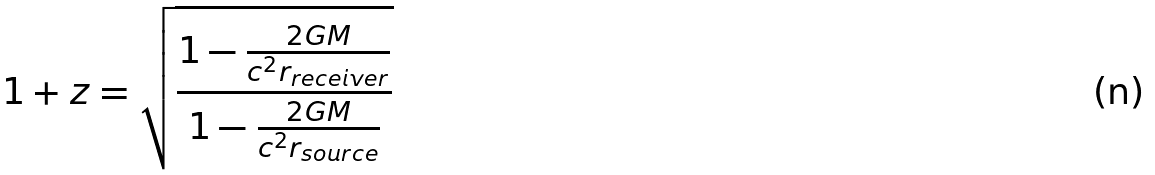Convert formula to latex. <formula><loc_0><loc_0><loc_500><loc_500>1 + z = { \sqrt { \frac { 1 - { \frac { 2 G M } { c ^ { 2 } r _ { r e c e i v e r } } } } { 1 - { \frac { 2 G M } { c ^ { 2 } r _ { s o u r c e } } } } } }</formula> 